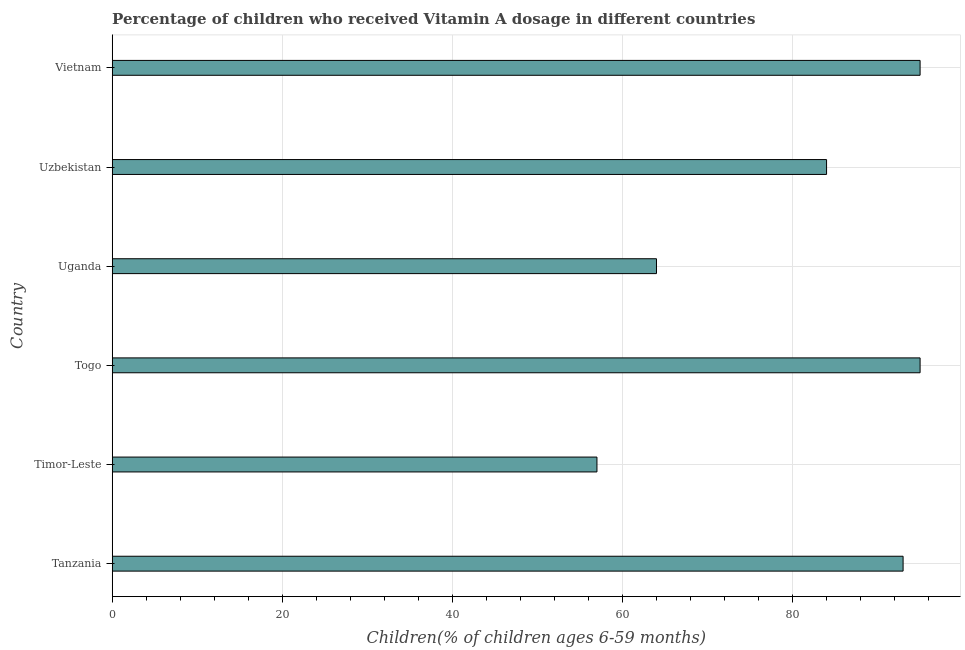Does the graph contain grids?
Provide a short and direct response. Yes. What is the title of the graph?
Give a very brief answer. Percentage of children who received Vitamin A dosage in different countries. What is the label or title of the X-axis?
Ensure brevity in your answer.  Children(% of children ages 6-59 months). What is the vitamin a supplementation coverage rate in Timor-Leste?
Provide a short and direct response. 57. In which country was the vitamin a supplementation coverage rate maximum?
Make the answer very short. Togo. In which country was the vitamin a supplementation coverage rate minimum?
Provide a short and direct response. Timor-Leste. What is the sum of the vitamin a supplementation coverage rate?
Ensure brevity in your answer.  488. What is the average vitamin a supplementation coverage rate per country?
Offer a very short reply. 81.33. What is the median vitamin a supplementation coverage rate?
Your response must be concise. 88.5. In how many countries, is the vitamin a supplementation coverage rate greater than 52 %?
Your answer should be compact. 6. What is the ratio of the vitamin a supplementation coverage rate in Togo to that in Uganda?
Provide a short and direct response. 1.48. Is the vitamin a supplementation coverage rate in Tanzania less than that in Timor-Leste?
Keep it short and to the point. No. Is the difference between the vitamin a supplementation coverage rate in Timor-Leste and Togo greater than the difference between any two countries?
Offer a very short reply. Yes. What is the difference between the highest and the second highest vitamin a supplementation coverage rate?
Your answer should be very brief. 0. Is the sum of the vitamin a supplementation coverage rate in Tanzania and Timor-Leste greater than the maximum vitamin a supplementation coverage rate across all countries?
Offer a terse response. Yes. How many bars are there?
Make the answer very short. 6. What is the difference between two consecutive major ticks on the X-axis?
Your answer should be very brief. 20. Are the values on the major ticks of X-axis written in scientific E-notation?
Offer a very short reply. No. What is the Children(% of children ages 6-59 months) in Tanzania?
Your answer should be compact. 93. What is the Children(% of children ages 6-59 months) in Timor-Leste?
Provide a short and direct response. 57. What is the Children(% of children ages 6-59 months) in Togo?
Your answer should be compact. 95. What is the Children(% of children ages 6-59 months) of Uzbekistan?
Provide a short and direct response. 84. What is the difference between the Children(% of children ages 6-59 months) in Tanzania and Togo?
Ensure brevity in your answer.  -2. What is the difference between the Children(% of children ages 6-59 months) in Tanzania and Uganda?
Give a very brief answer. 29. What is the difference between the Children(% of children ages 6-59 months) in Tanzania and Uzbekistan?
Give a very brief answer. 9. What is the difference between the Children(% of children ages 6-59 months) in Tanzania and Vietnam?
Offer a very short reply. -2. What is the difference between the Children(% of children ages 6-59 months) in Timor-Leste and Togo?
Your answer should be compact. -38. What is the difference between the Children(% of children ages 6-59 months) in Timor-Leste and Vietnam?
Your answer should be very brief. -38. What is the difference between the Children(% of children ages 6-59 months) in Togo and Uzbekistan?
Keep it short and to the point. 11. What is the difference between the Children(% of children ages 6-59 months) in Uganda and Vietnam?
Your answer should be compact. -31. What is the ratio of the Children(% of children ages 6-59 months) in Tanzania to that in Timor-Leste?
Your response must be concise. 1.63. What is the ratio of the Children(% of children ages 6-59 months) in Tanzania to that in Togo?
Provide a succinct answer. 0.98. What is the ratio of the Children(% of children ages 6-59 months) in Tanzania to that in Uganda?
Offer a very short reply. 1.45. What is the ratio of the Children(% of children ages 6-59 months) in Tanzania to that in Uzbekistan?
Ensure brevity in your answer.  1.11. What is the ratio of the Children(% of children ages 6-59 months) in Tanzania to that in Vietnam?
Offer a terse response. 0.98. What is the ratio of the Children(% of children ages 6-59 months) in Timor-Leste to that in Togo?
Make the answer very short. 0.6. What is the ratio of the Children(% of children ages 6-59 months) in Timor-Leste to that in Uganda?
Provide a short and direct response. 0.89. What is the ratio of the Children(% of children ages 6-59 months) in Timor-Leste to that in Uzbekistan?
Your answer should be very brief. 0.68. What is the ratio of the Children(% of children ages 6-59 months) in Togo to that in Uganda?
Make the answer very short. 1.48. What is the ratio of the Children(% of children ages 6-59 months) in Togo to that in Uzbekistan?
Make the answer very short. 1.13. What is the ratio of the Children(% of children ages 6-59 months) in Togo to that in Vietnam?
Provide a succinct answer. 1. What is the ratio of the Children(% of children ages 6-59 months) in Uganda to that in Uzbekistan?
Make the answer very short. 0.76. What is the ratio of the Children(% of children ages 6-59 months) in Uganda to that in Vietnam?
Your response must be concise. 0.67. What is the ratio of the Children(% of children ages 6-59 months) in Uzbekistan to that in Vietnam?
Make the answer very short. 0.88. 